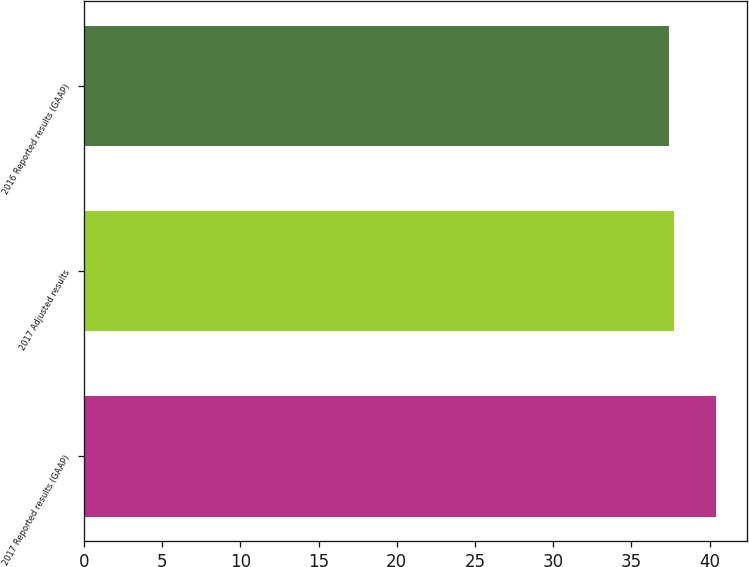Convert chart. <chart><loc_0><loc_0><loc_500><loc_500><bar_chart><fcel>2017 Reported results (GAAP)<fcel>2017 Adjusted results<fcel>2016 Reported results (GAAP)<nl><fcel>40.4<fcel>37.7<fcel>37.4<nl></chart> 